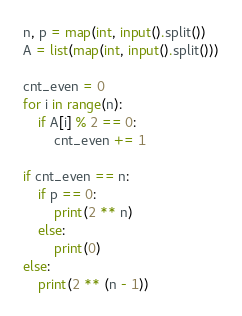Convert code to text. <code><loc_0><loc_0><loc_500><loc_500><_Python_>n, p = map(int, input().split())
A = list(map(int, input().split()))

cnt_even = 0
for i in range(n):
	if A[i] % 2 == 0:
		cnt_even += 1

if cnt_even == n:
	if p == 0:
		print(2 ** n)
	else:
		print(0)
else:
	print(2 ** (n - 1))</code> 